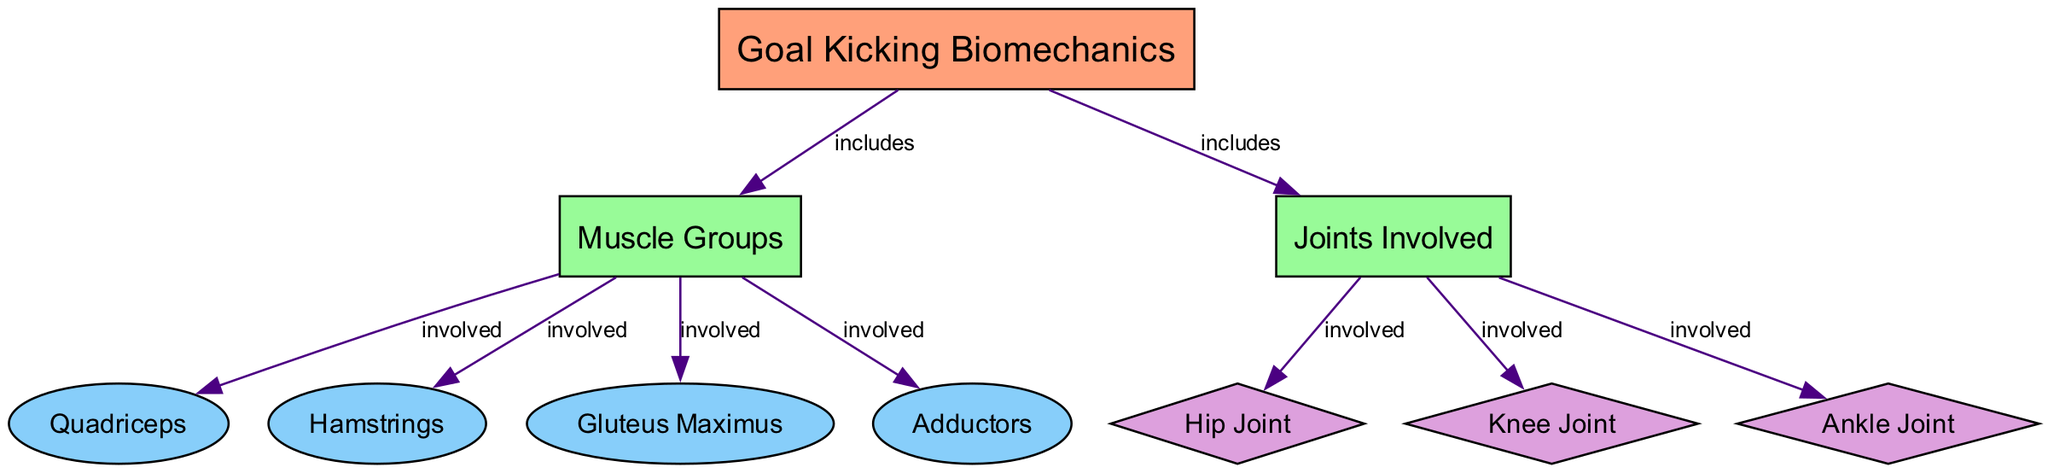What is the central topic of the diagram? The central node labeled "Goal Kicking Biomechanics" defines the main subject of the diagram. It represents the overarching concept that encompasses the various components illustrated in the diagram.
Answer: Goal Kicking Biomechanics How many muscle groups are included in the diagram? From the central node, there are edges leading to four muscle-specific nodes (Quadriceps, Hamstrings, Gluteus Maximus, Adductors). Thus, counting these nodes indicates there are four muscle groups included.
Answer: 4 Which muscle is involved in the goal kicking process? The diagram specifically highlights Quadriceps, Hamstrings, Gluteus Maximus, and Adductors as connected to the "Muscle Groups" category. Any of these names can be an answer; however, we can choose one, such as "Quadriceps."
Answer: Quadriceps What joints are involved in the biomechanical process? The diagram indicates there are three joint-specific nodes connected to the "Joints Involved" category (Hip Joint, Knee Joint, Ankle Joint). Love to count the nodes by identifying these joint names leads to the conclusion.
Answer: 3 What is the relationship between muscle groups and joints in the diagram? The edges indicate that both muscle groups and joints are essential components of the goal-kicking biomechanics. Each muscle group is linked to the process, and similarly, each joint plays a role in the movement, establishing that they are both critical elements in this biomechanical sequence.
Answer: Both are critical elements Which joint is directly associated with the knee? The edge directly connects the central topic "Goal Kicking Biomechanics" to the node "Knee Joint," indicating that it is one of the joints involved in this specific movement. Thus, the answer is "Knee Joint."
Answer: Knee Joint What type of shape represents the muscles in the diagram? According to the diagram's style, muscle nodes are indicated as ellipses, differentiating them from other types of nodes representing joints and categories.
Answer: Ellipse Which muscle is closer to the hip joint in the diagram? The muscle "Gluteus Maximus" is visually and conceptually closer to the "Hip Joint" based on the arrangement of the nodes and edges that show it is involved.
Answer: Gluteus Maximus How many relationships are shown between muscle groups and joints? By counting the edges connecting the "Muscle Groups" and "Joints Involved" categories, we identify specific relationships for several muscles linked to the knee, hip, and ankle joints, resulting in a total of seven distinct edges representing these relationships.
Answer: 7 What type of diagram is this? The diagram specifically focuses on the biomechanics associated with activities such as goal-kicking, linking anatomy and movement sciences which characterize it as a biomedical diagram.
Answer: Biomedical Diagram 